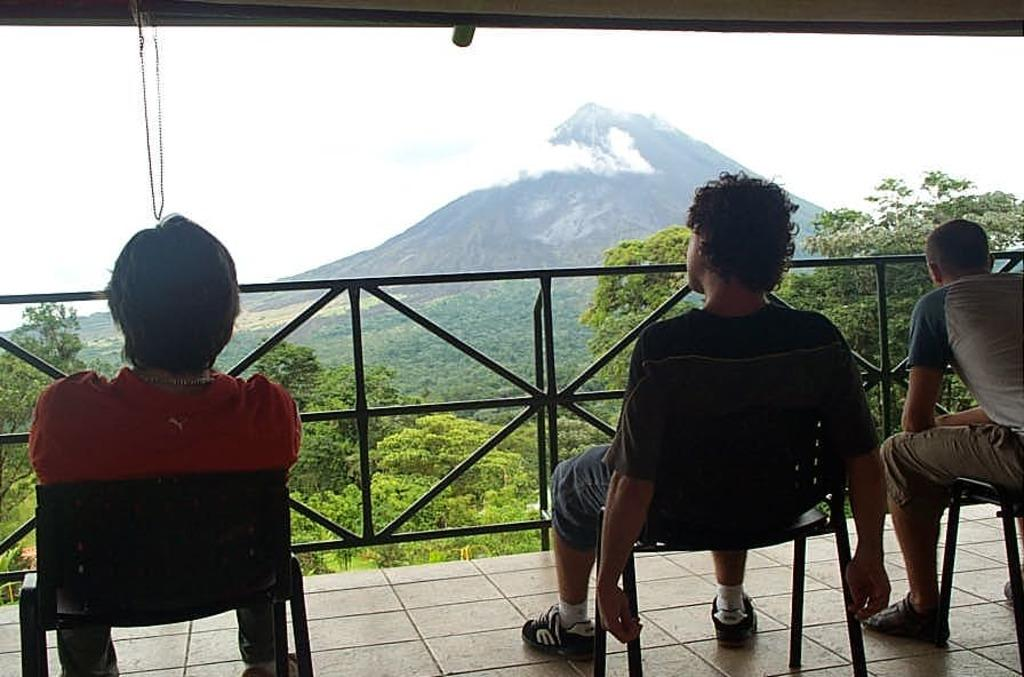How many people are sitting in the foreground of the image? There are three persons sitting on chairs in the foreground. What can be seen in the background of the image? There is a fence, trees, mountains, and the sky visible in the background. Can you describe the time of day when the image was taken? The image was taken during the day. What type of crow can be seen flying over the mountains in the image? There is no crow present in the image; it only features three persons sitting on chairs in the foreground and various background elements. Is there a volcano visible in the image? No, there is no volcano present in the image; it only features a fence, trees, mountains, and the sky in the background. 